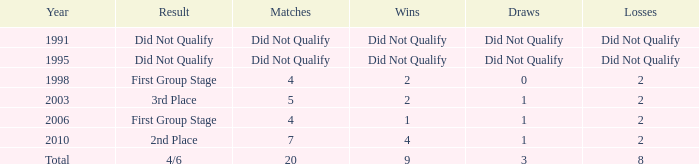What was the result for the team with 3 draws? 4/6. 